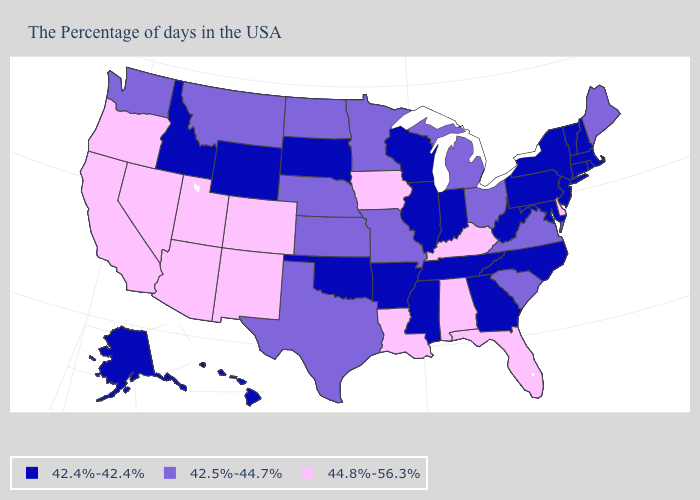How many symbols are there in the legend?
Short answer required. 3. What is the value of Tennessee?
Concise answer only. 42.4%-42.4%. Which states have the lowest value in the USA?
Keep it brief. Massachusetts, Rhode Island, New Hampshire, Vermont, Connecticut, New York, New Jersey, Maryland, Pennsylvania, North Carolina, West Virginia, Georgia, Indiana, Tennessee, Wisconsin, Illinois, Mississippi, Arkansas, Oklahoma, South Dakota, Wyoming, Idaho, Alaska, Hawaii. Does the first symbol in the legend represent the smallest category?
Write a very short answer. Yes. What is the value of Maine?
Write a very short answer. 42.5%-44.7%. Name the states that have a value in the range 42.5%-44.7%?
Quick response, please. Maine, Virginia, South Carolina, Ohio, Michigan, Missouri, Minnesota, Kansas, Nebraska, Texas, North Dakota, Montana, Washington. Name the states that have a value in the range 42.4%-42.4%?
Quick response, please. Massachusetts, Rhode Island, New Hampshire, Vermont, Connecticut, New York, New Jersey, Maryland, Pennsylvania, North Carolina, West Virginia, Georgia, Indiana, Tennessee, Wisconsin, Illinois, Mississippi, Arkansas, Oklahoma, South Dakota, Wyoming, Idaho, Alaska, Hawaii. Does Idaho have the same value as Virginia?
Quick response, please. No. Does the first symbol in the legend represent the smallest category?
Concise answer only. Yes. Does Missouri have the same value as Texas?
Give a very brief answer. Yes. What is the value of Missouri?
Short answer required. 42.5%-44.7%. Does New Jersey have a lower value than Arkansas?
Concise answer only. No. Does the map have missing data?
Write a very short answer. No. Which states hav the highest value in the MidWest?
Keep it brief. Iowa. 